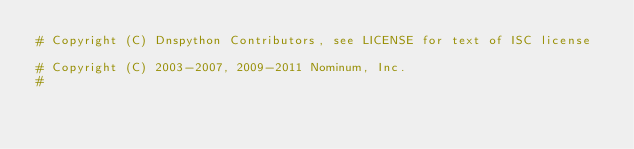Convert code to text. <code><loc_0><loc_0><loc_500><loc_500><_Python_># Copyright (C) Dnspython Contributors, see LICENSE for text of ISC license

# Copyright (C) 2003-2007, 2009-2011 Nominum, Inc.
#</code> 